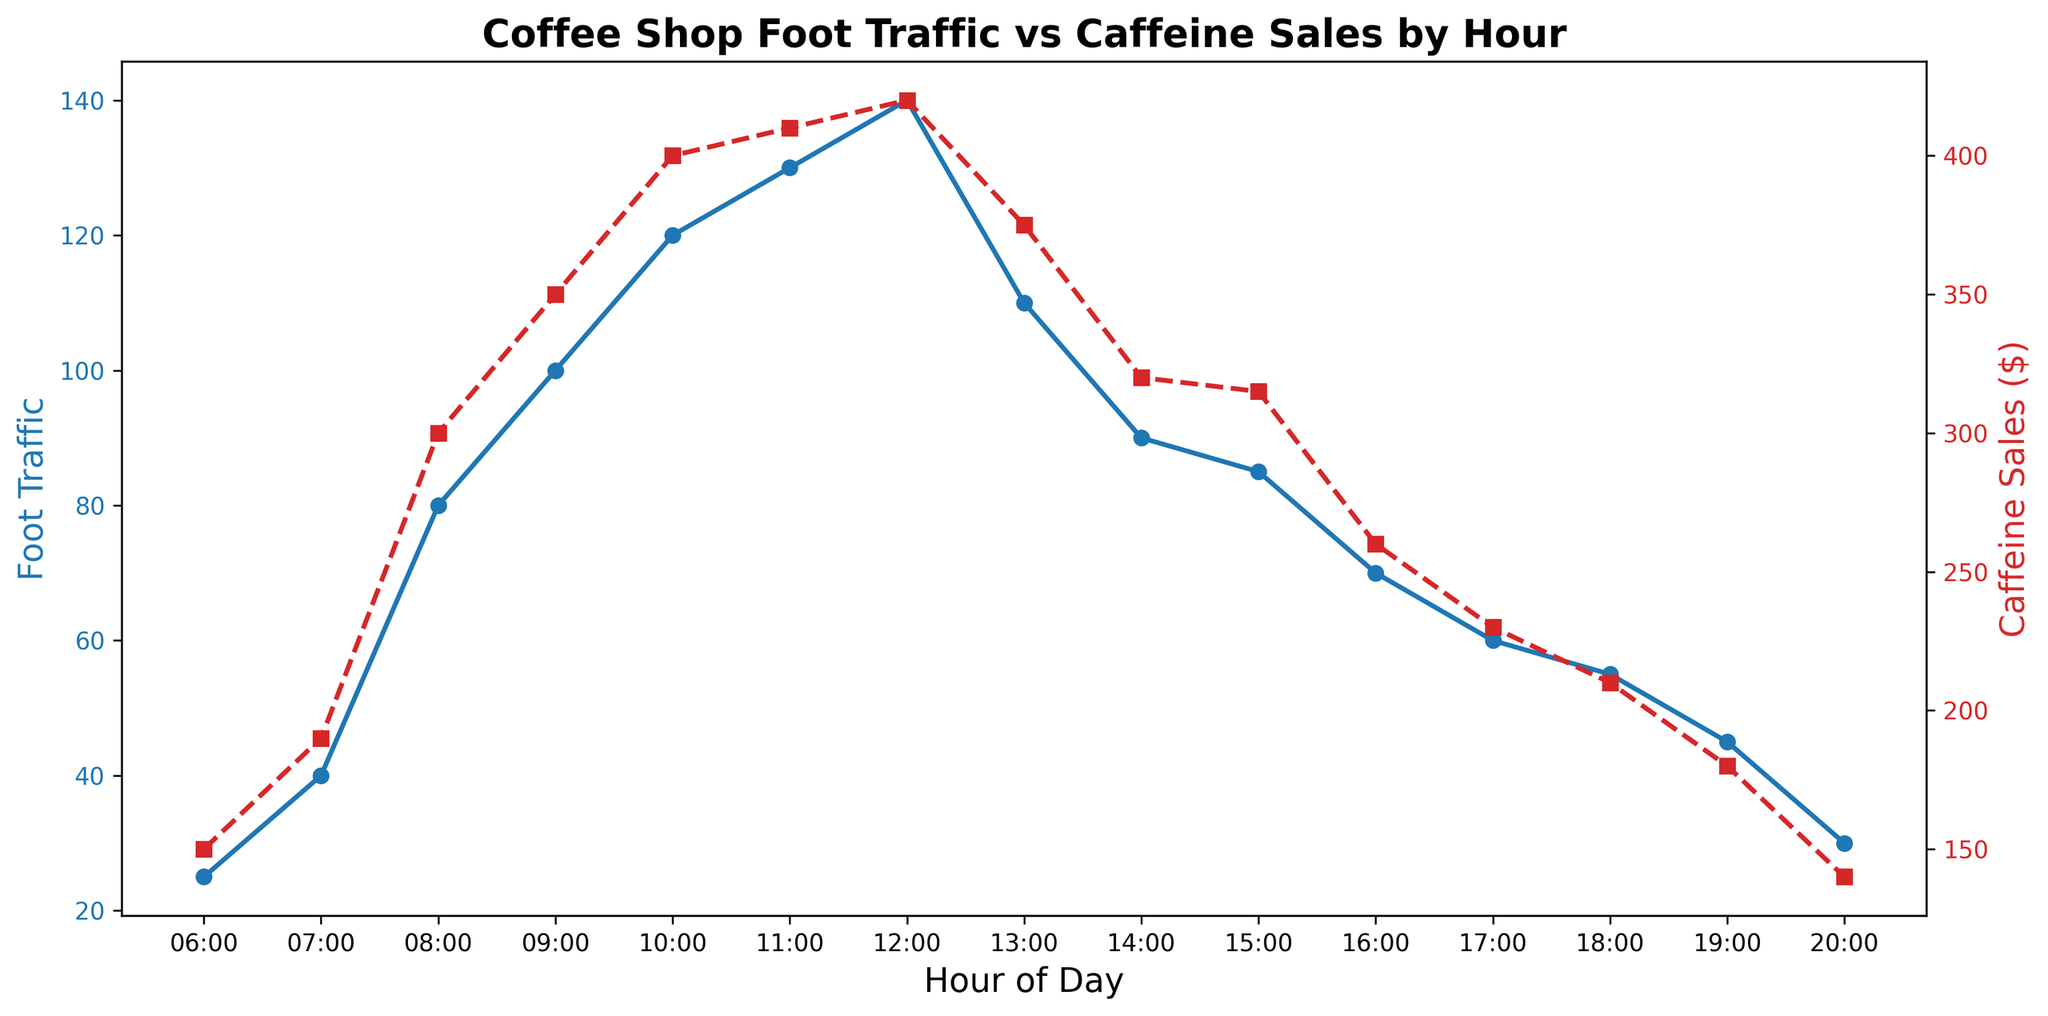What is the peak hour for Foot Traffic? The peak hour for Foot Traffic is identified by looking for the highest blue line point on the primary y-axis. The highest Foot Traffic value is 140, which occurs at 12:00.
Answer: 12:00 At what hour do Caffeine Sales reach their maximum? To find the peak hour for Caffeine Sales, look for the highest point on the red dashed line representing Caffeine Sales on the secondary y-axis. The highest Caffeine Sales value is 420, which occurs at 12:00.
Answer: 12:00 How does Foot Traffic at 09:00 compare to 10:00? Compare the Foot Traffic values at 09:00 and 10:00 by referring to the blue line. At 09:00, Foot Traffic is 100, and at 10:00, it is 120, meaning Foot Traffic is higher at 10:00.
Answer: 10:00 has higher Foot Traffic What is the difference between Foot Traffic and Caffeine Sales at 08:00? To find the difference, subtract the Foot Traffic value from the Caffeine Sales value at 08:00. Caffeine Sales at 08:00 are 300, and Foot Traffic is 80, so the difference is 300 - 80 = 220.
Answer: 220 What is the trend in Caffeine Sales from 06:00 to 12:00? Analyze the red dashed line from 06:00 to 12:00. The Caffeine Sales increase steadily from 150 at 06:00 and peak at 420 at 12:00, indicating a general upward trend.
Answer: Upward trend When is the smallest gap between Foot Traffic and Caffeine Sales? To find the smallest gap, calculate the absolute difference between Foot Traffic and Caffeine Sales for each hour. The smallest difference is 15 at 11:00 (Foot Traffic 130, Caffeine Sales 410).
Answer: 11:00 What is the overall pattern in Foot Traffic from morning to evening? The blue line shows Foot Traffic increasing from 25 at 06:00, peaking at 140 at 12:00, and then decreasing gradually throughout the rest of the day to 30 at 20:00, indicating a rise and fall pattern.
Answer: Rise in morning, peak at noon, decline in evening What is the average Foot Traffic from 06:00 to 12:00? Sum the Foot Traffic values from 06:00 to 12:00 and divide by the number of hours. (25 + 40 + 80 + 100 + 120 + 130 + 140) / 7 = 635 / 7 = ~90.7.
Answer: ~90.7 Compare the slopes of the Foot Traffic and Caffeine Sales lines between 10:00 and 12:00. Examine the change in values for both lines between 10:00 and 12:00. Foot Traffic goes from 120 to 140 (increase of 20), and Caffeine Sales go from 400 to 420 (increase of 20). The slopes are equal between these hours.
Answer: Equal slopes What hour has the smallest Foot Traffic but relatively high Caffeine Sales, and what might this imply? Look for the hour with low Foot Traffic and relatively higher Caffeine Sales. At 06:00, Foot Traffic is 25, and Caffeine Sales are 150, implying that even with low traffic, early customers buy more caffeine.
Answer: 06:00 What time interval sees the sharpest drop in Foot Traffic? Observe the blue line for the interval with the steepest decline in Foot Traffic. The sharpest drop is from 12:00 to 14:00, where Foot Traffic drops from 140 to 90.
Answer: 12:00 to 14:00 